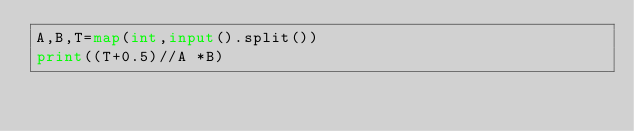<code> <loc_0><loc_0><loc_500><loc_500><_Python_>A,B,T=map(int,input().split())
print((T+0.5)//A *B)</code> 